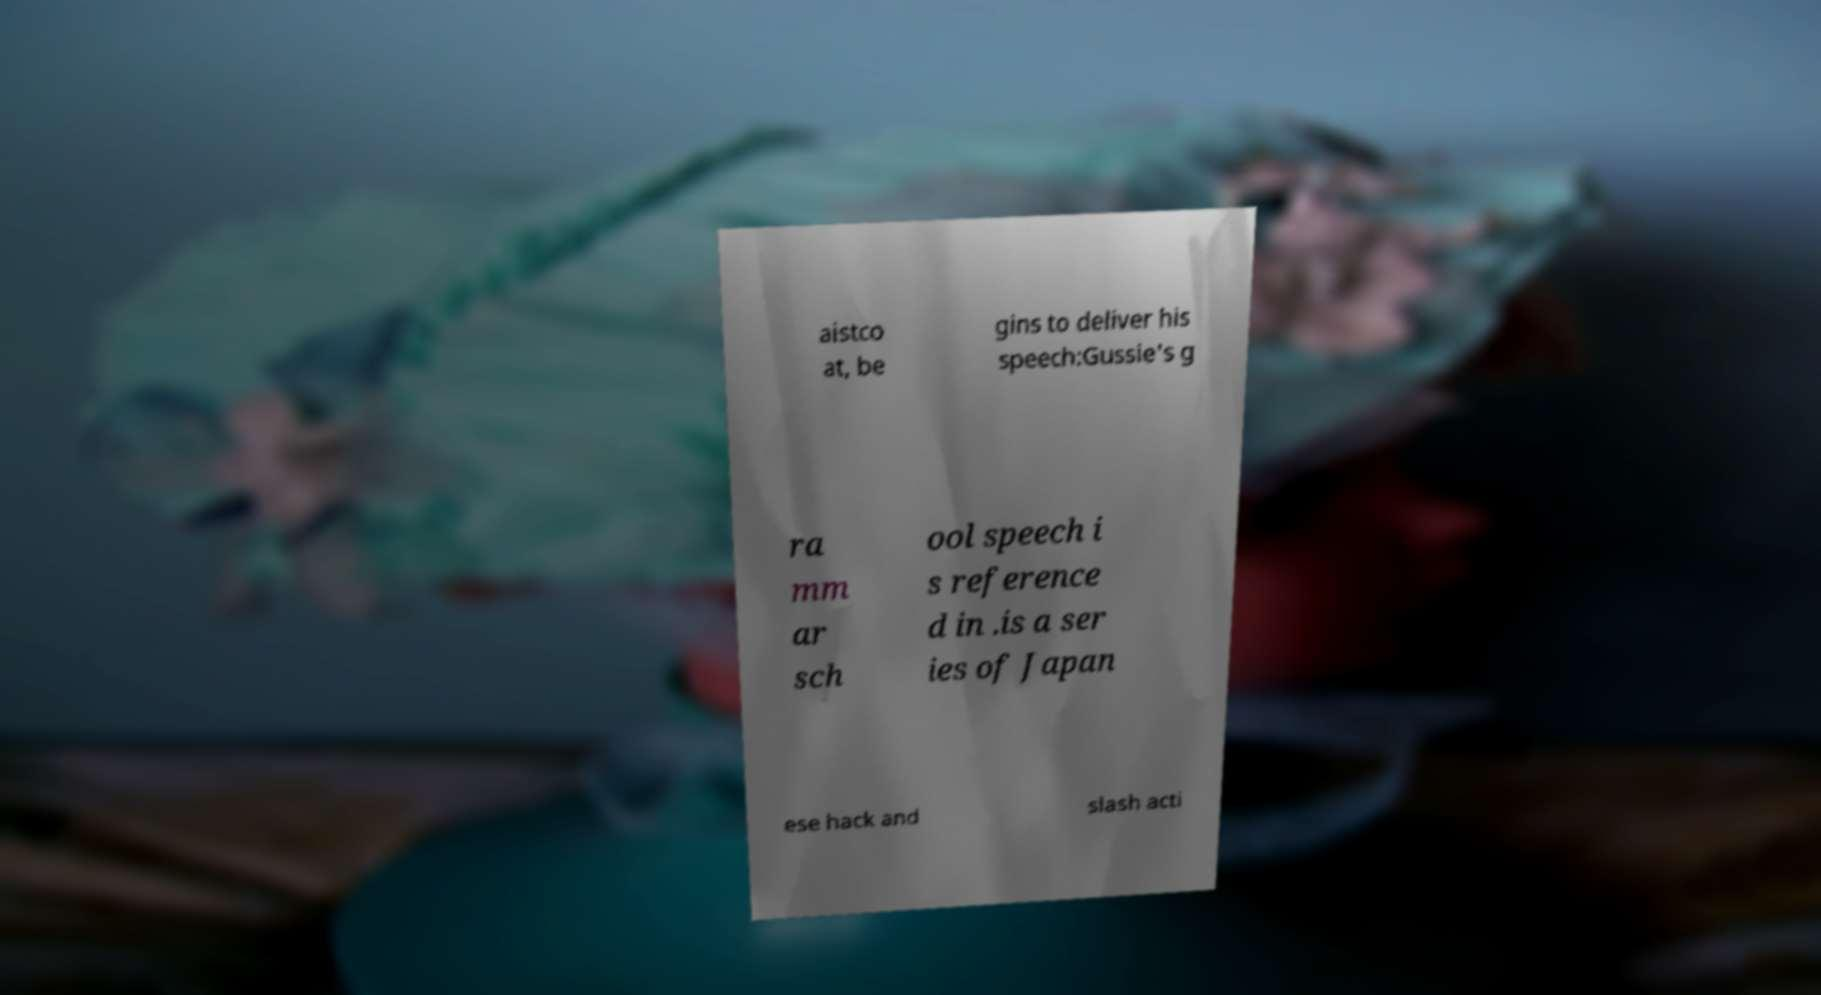Can you accurately transcribe the text from the provided image for me? aistco at, be gins to deliver his speech:Gussie's g ra mm ar sch ool speech i s reference d in .is a ser ies of Japan ese hack and slash acti 